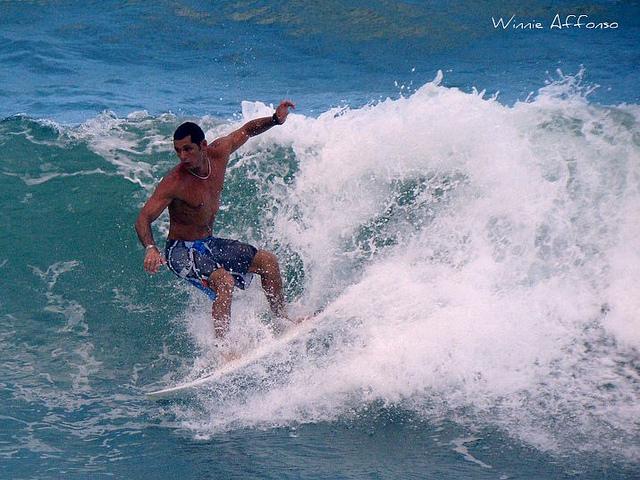What is the man standing on?
Keep it brief. Surfboard. Is the person wearing jewelry?
Write a very short answer. Yes. Is the surfer wearing a bodysuit?
Concise answer only. No. Is the man wearing a shirt?
Short answer required. No. Is this person wearing a wetsuit?
Answer briefly. No. 